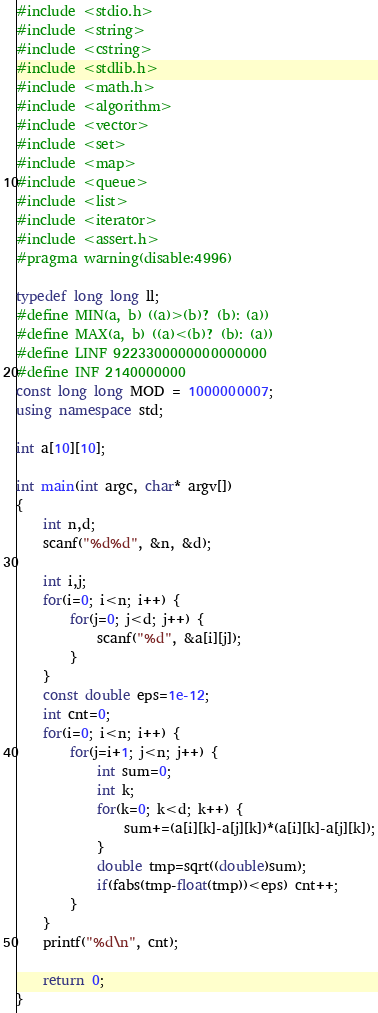Convert code to text. <code><loc_0><loc_0><loc_500><loc_500><_C++_>#include <stdio.h>
#include <string>
#include <cstring>
#include <stdlib.h>
#include <math.h>
#include <algorithm>
#include <vector>
#include <set>
#include <map>
#include <queue>
#include <list>
#include <iterator>
#include <assert.h>
#pragma warning(disable:4996) 
 
typedef long long ll;
#define MIN(a, b) ((a)>(b)? (b): (a))
#define MAX(a, b) ((a)<(b)? (b): (a))
#define LINF 9223300000000000000
#define INF 2140000000
const long long MOD = 1000000007;
using namespace std;

int a[10][10];

int main(int argc, char* argv[])
{
    int n,d;
    scanf("%d%d", &n, &d);

    int i,j;
    for(i=0; i<n; i++) {
        for(j=0; j<d; j++) {
            scanf("%d", &a[i][j]);
        }
    }
    const double eps=1e-12;
    int cnt=0;
    for(i=0; i<n; i++) {
        for(j=i+1; j<n; j++) {
            int sum=0;
            int k;
            for(k=0; k<d; k++) {
                sum+=(a[i][k]-a[j][k])*(a[i][k]-a[j][k]);
            }
            double tmp=sqrt((double)sum);
            if(fabs(tmp-float(tmp))<eps) cnt++;
        }
    }
    printf("%d\n", cnt);

    return 0;
}
</code> 